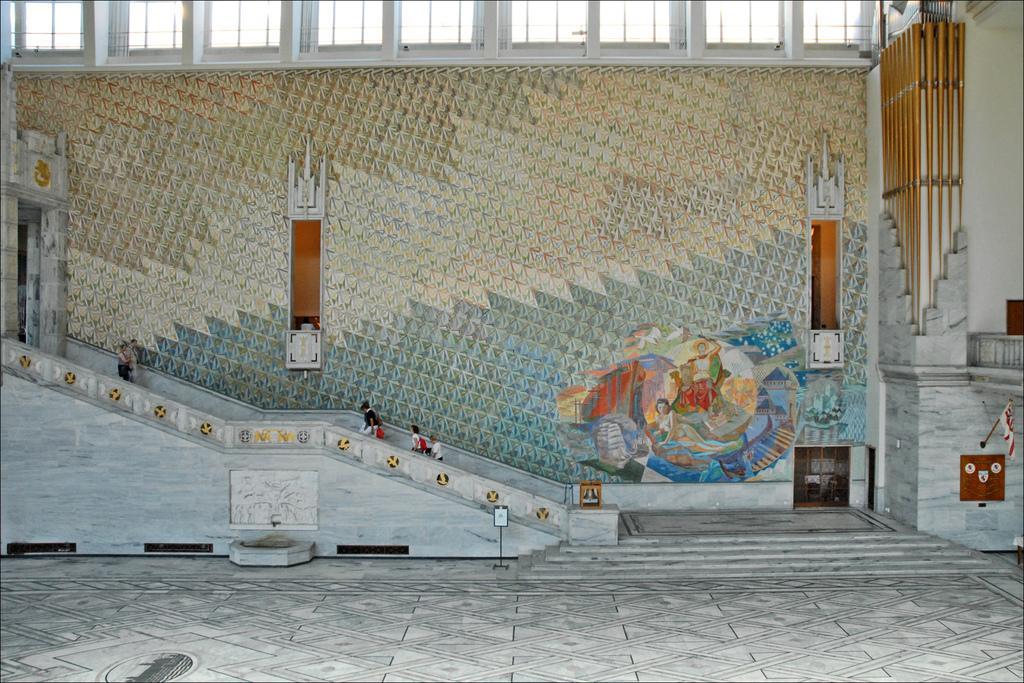Can you describe this image briefly? In this image I can see in the middle few people are walking through the stairs and there is a painting to this wall. At the top there are glasses. 